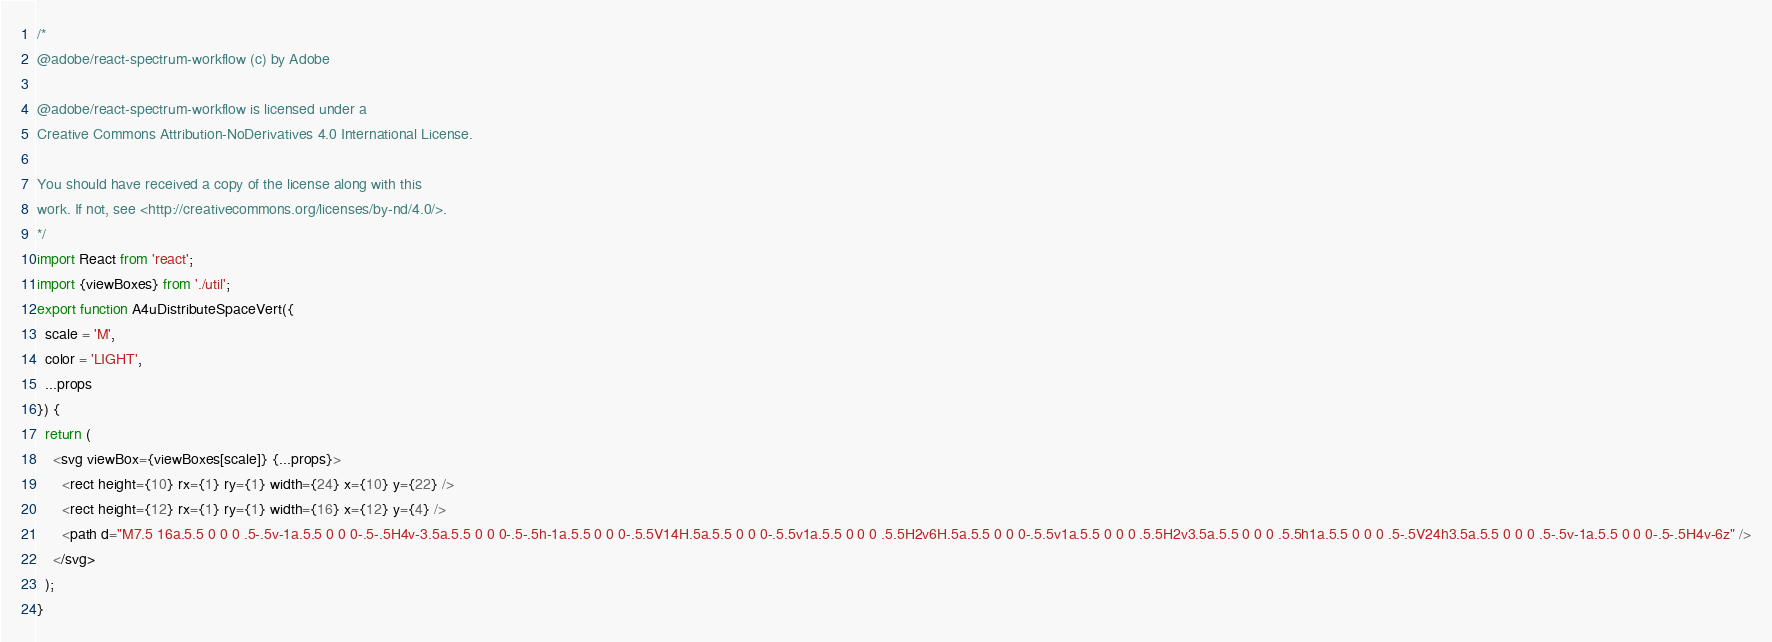<code> <loc_0><loc_0><loc_500><loc_500><_JavaScript_>/*
@adobe/react-spectrum-workflow (c) by Adobe

@adobe/react-spectrum-workflow is licensed under a
Creative Commons Attribution-NoDerivatives 4.0 International License.

You should have received a copy of the license along with this
work. If not, see <http://creativecommons.org/licenses/by-nd/4.0/>.
*/
import React from 'react';
import {viewBoxes} from './util';
export function A4uDistributeSpaceVert({
  scale = 'M',
  color = 'LIGHT',
  ...props
}) {
  return (
    <svg viewBox={viewBoxes[scale]} {...props}>
      <rect height={10} rx={1} ry={1} width={24} x={10} y={22} />
      <rect height={12} rx={1} ry={1} width={16} x={12} y={4} />
      <path d="M7.5 16a.5.5 0 0 0 .5-.5v-1a.5.5 0 0 0-.5-.5H4v-3.5a.5.5 0 0 0-.5-.5h-1a.5.5 0 0 0-.5.5V14H.5a.5.5 0 0 0-.5.5v1a.5.5 0 0 0 .5.5H2v6H.5a.5.5 0 0 0-.5.5v1a.5.5 0 0 0 .5.5H2v3.5a.5.5 0 0 0 .5.5h1a.5.5 0 0 0 .5-.5V24h3.5a.5.5 0 0 0 .5-.5v-1a.5.5 0 0 0-.5-.5H4v-6z" />
    </svg>
  );
}
</code> 